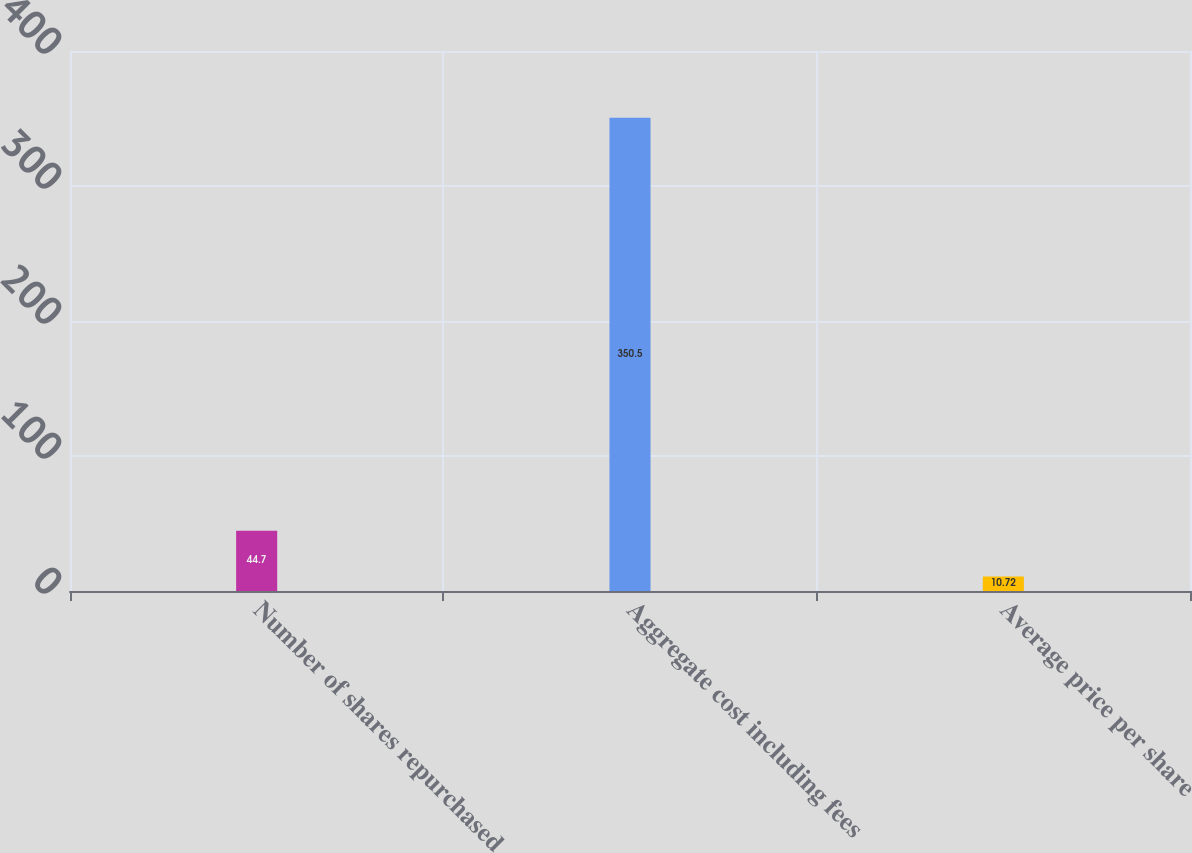Convert chart to OTSL. <chart><loc_0><loc_0><loc_500><loc_500><bar_chart><fcel>Number of shares repurchased<fcel>Aggregate cost including fees<fcel>Average price per share<nl><fcel>44.7<fcel>350.5<fcel>10.72<nl></chart> 